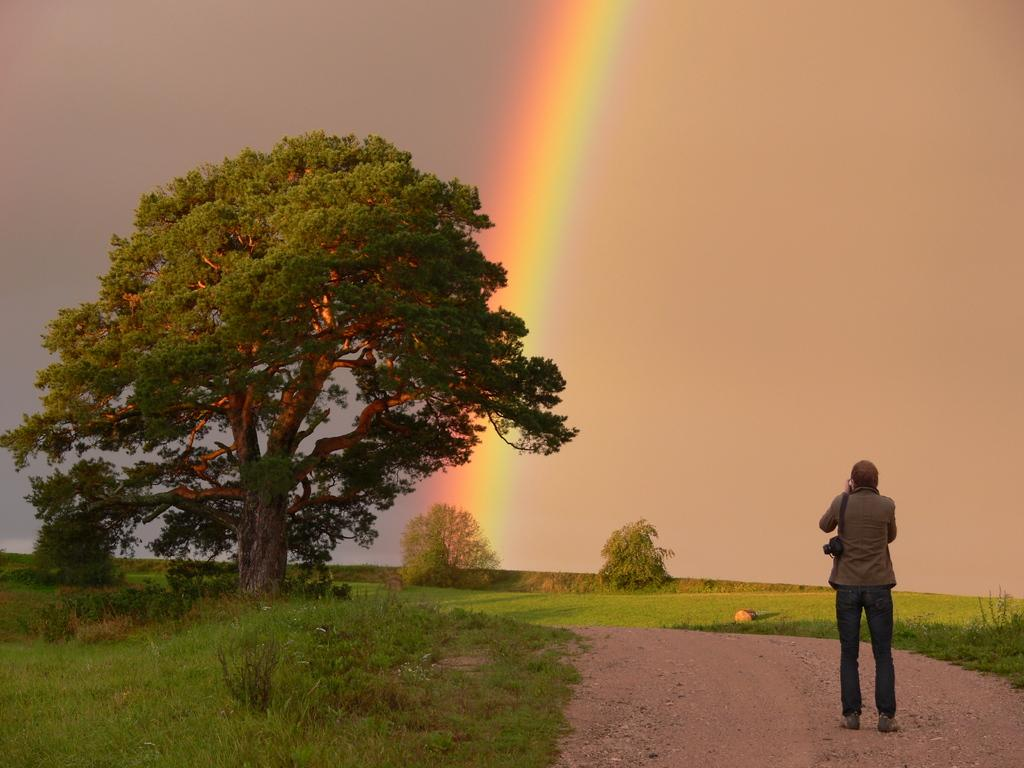What is the main subject in the image? There is a person standing in the image. What type of natural environment is depicted in the image? There are trees with branches and leaves, grass, and plants in the image. What can be seen in the sky in the image? A rainbow is visible in the sky. What type of comfort can be found in the verse written on the map in the image? There is no map or verse present in the image, so comfort cannot be found in a verse written on a map. 